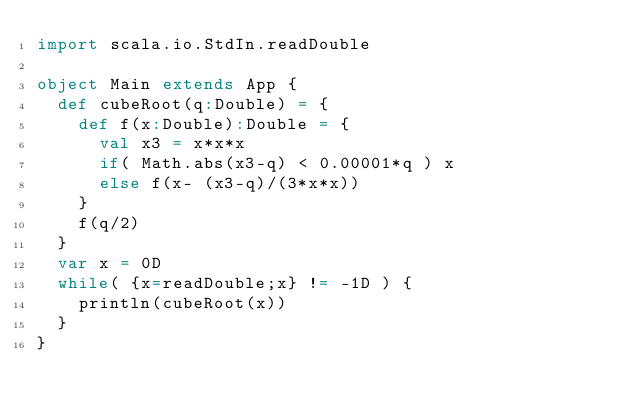Convert code to text. <code><loc_0><loc_0><loc_500><loc_500><_Scala_>import scala.io.StdIn.readDouble

object Main extends App {
  def cubeRoot(q:Double) = {
    def f(x:Double):Double = {
      val x3 = x*x*x
      if( Math.abs(x3-q) < 0.00001*q ) x
      else f(x- (x3-q)/(3*x*x))
    }
    f(q/2)
  }
  var x = 0D
  while( {x=readDouble;x} != -1D ) {
    println(cubeRoot(x))
  }
}</code> 